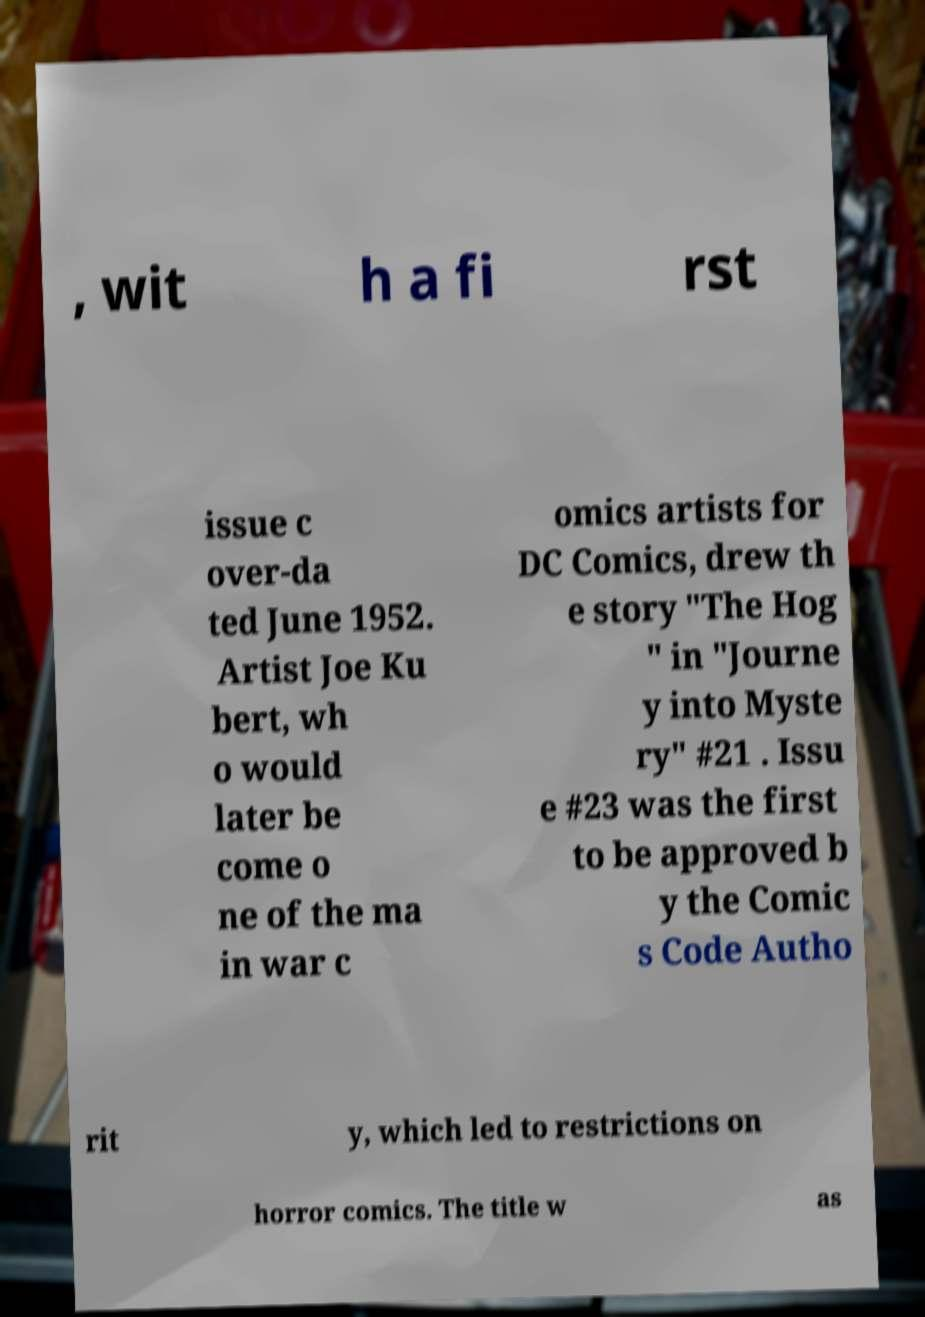Could you assist in decoding the text presented in this image and type it out clearly? , wit h a fi rst issue c over-da ted June 1952. Artist Joe Ku bert, wh o would later be come o ne of the ma in war c omics artists for DC Comics, drew th e story "The Hog " in "Journe y into Myste ry" #21 . Issu e #23 was the first to be approved b y the Comic s Code Autho rit y, which led to restrictions on horror comics. The title w as 